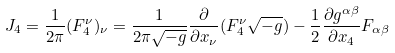Convert formula to latex. <formula><loc_0><loc_0><loc_500><loc_500>J _ { 4 } = \frac { 1 } { 2 \pi } ( F ^ { \nu } _ { 4 } ) _ { \nu } = \frac { 1 } { 2 \pi \sqrt { - g } } \frac { \partial } { \partial x _ { \nu } } ( F ^ { \nu } _ { 4 } \sqrt { - g } ) - \frac { 1 } { 2 } \frac { \partial g ^ { \alpha \beta } } { \partial x _ { 4 } } F _ { \alpha \beta }</formula> 